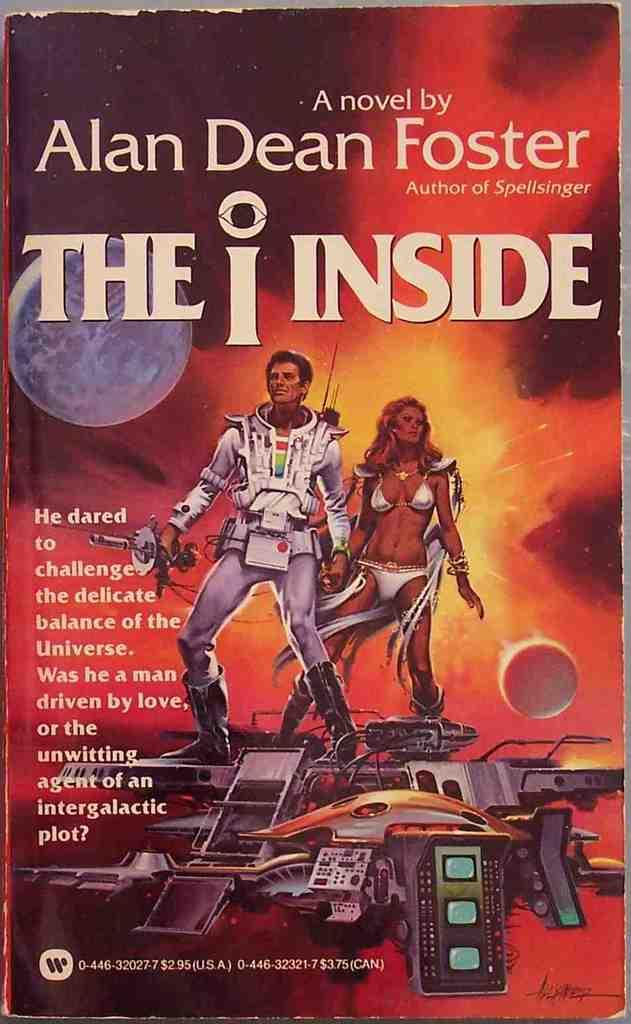<image>
Offer a succinct explanation of the picture presented. The cover of the book The Inside by Alan Dean Foster indicates that the story is set in space. 